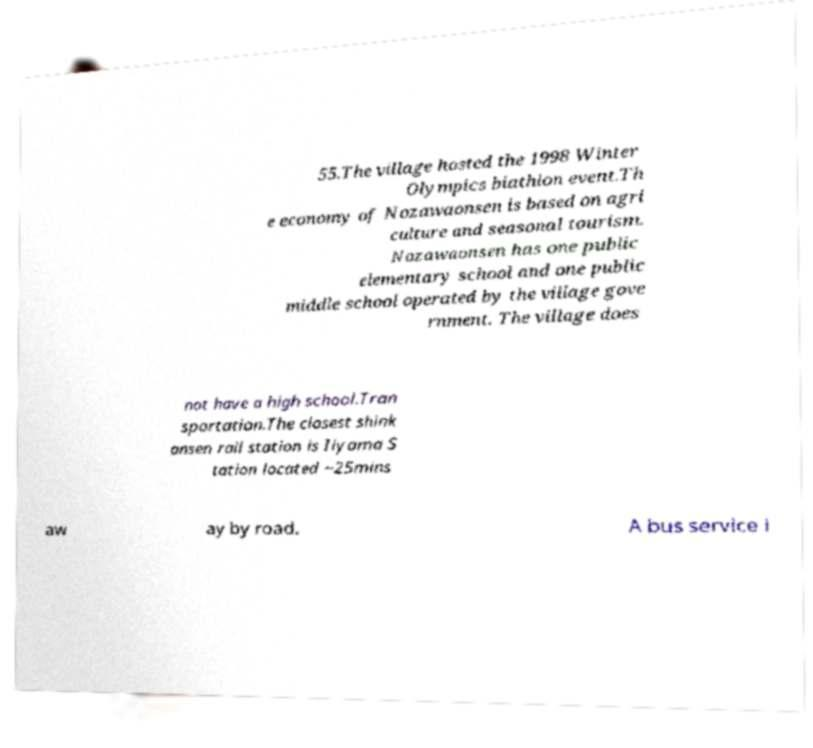Can you read and provide the text displayed in the image?This photo seems to have some interesting text. Can you extract and type it out for me? 55.The village hosted the 1998 Winter Olympics biathlon event.Th e economy of Nozawaonsen is based on agri culture and seasonal tourism. Nozawaonsen has one public elementary school and one public middle school operated by the village gove rnment. The village does not have a high school.Tran sportation.The closest shink ansen rail station is Iiyama S tation located ~25mins aw ay by road. A bus service i 